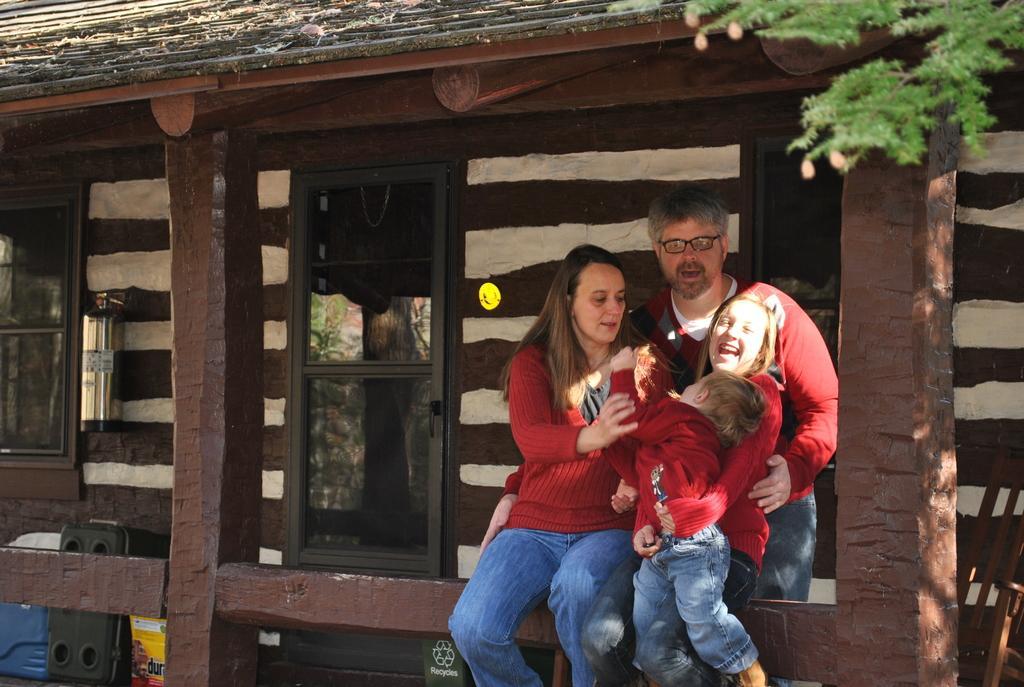Please provide a concise description of this image. In this image there are some persons are in middle of this image and there is house in the background. 